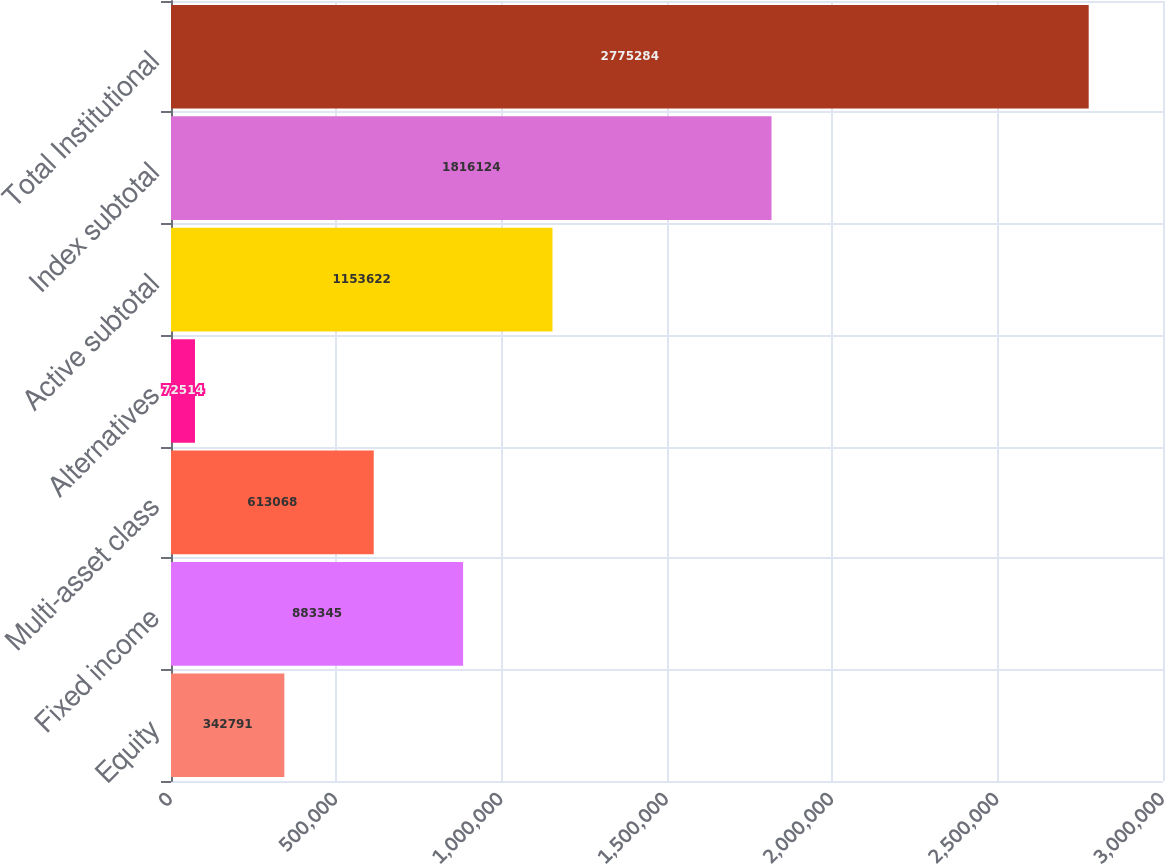<chart> <loc_0><loc_0><loc_500><loc_500><bar_chart><fcel>Equity<fcel>Fixed income<fcel>Multi-asset class<fcel>Alternatives<fcel>Active subtotal<fcel>Index subtotal<fcel>Total Institutional<nl><fcel>342791<fcel>883345<fcel>613068<fcel>72514<fcel>1.15362e+06<fcel>1.81612e+06<fcel>2.77528e+06<nl></chart> 